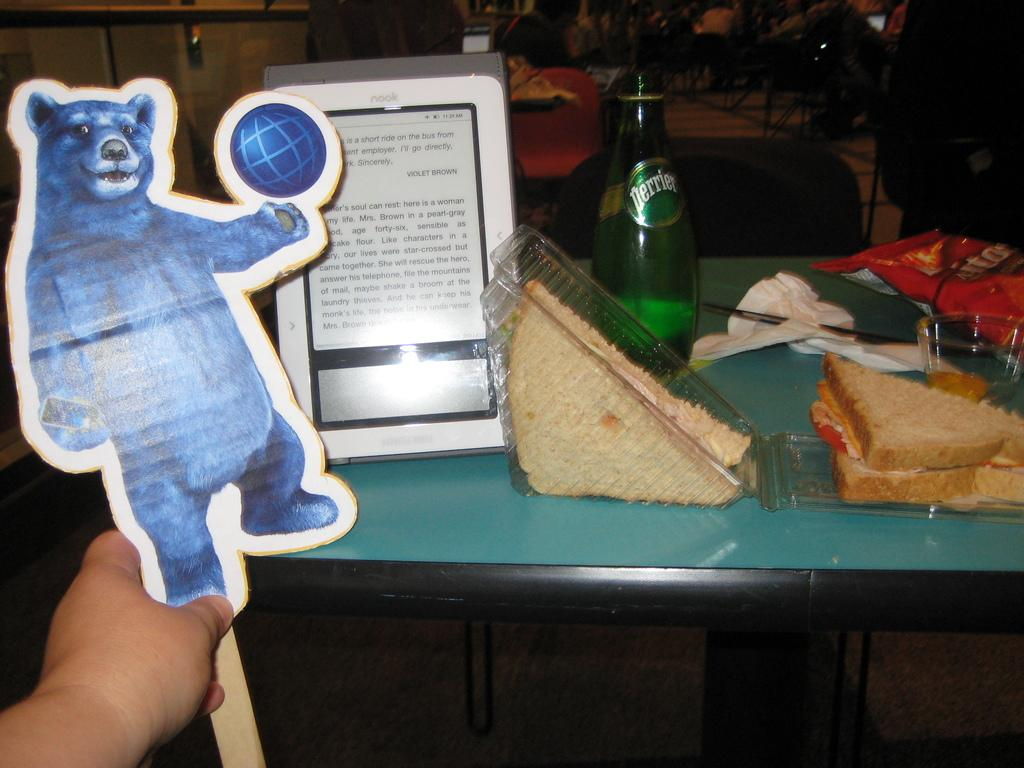Provide a one-sentence caption for the provided image. A table with food and a bottle of Perrier water. 